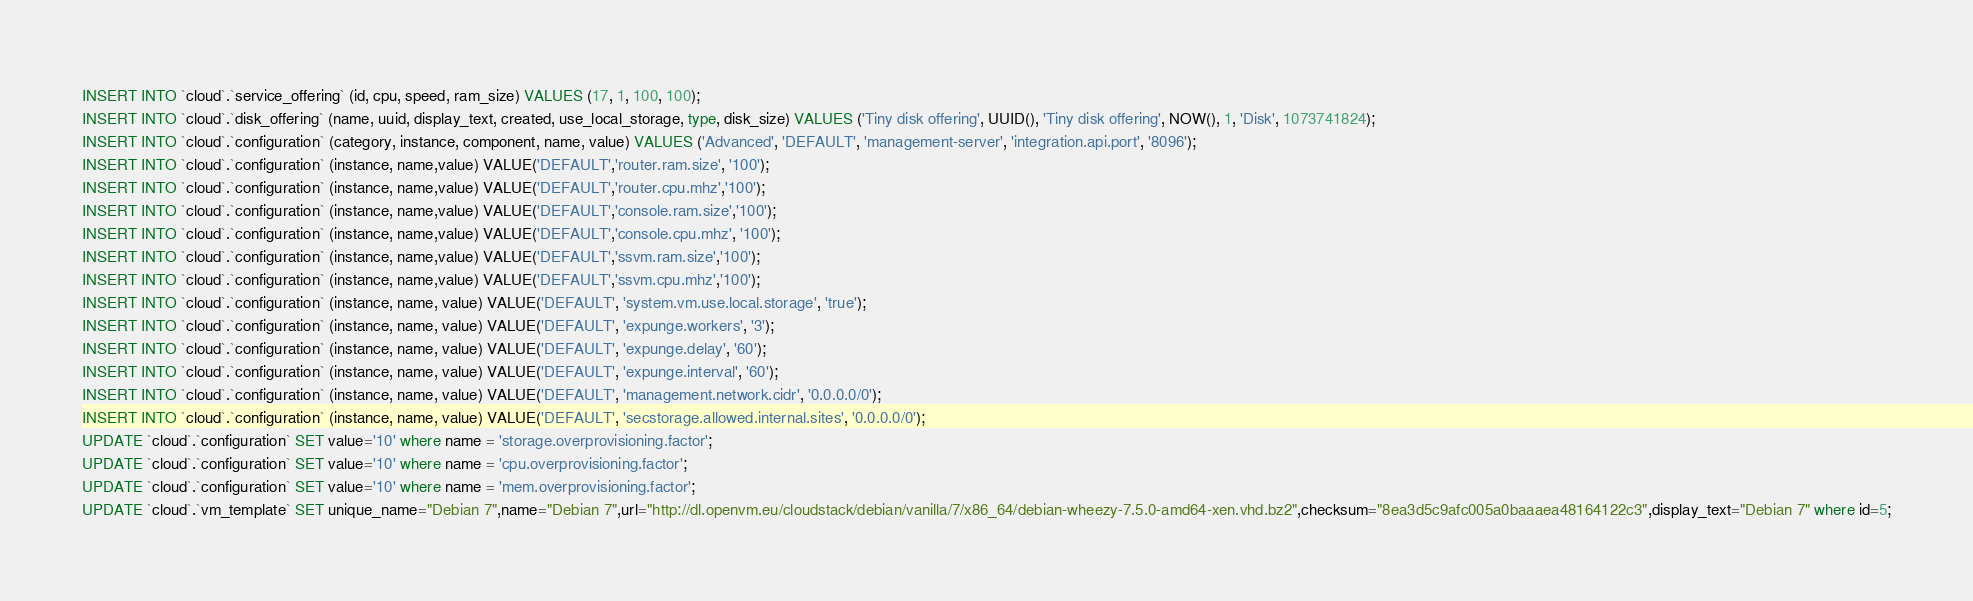<code> <loc_0><loc_0><loc_500><loc_500><_SQL_>INSERT INTO `cloud`.`service_offering` (id, cpu, speed, ram_size) VALUES (17, 1, 100, 100);
INSERT INTO `cloud`.`disk_offering` (name, uuid, display_text, created, use_local_storage, type, disk_size) VALUES ('Tiny disk offering', UUID(), 'Tiny disk offering', NOW(), 1, 'Disk', 1073741824);
INSERT INTO `cloud`.`configuration` (category, instance, component, name, value) VALUES ('Advanced', 'DEFAULT', 'management-server', 'integration.api.port', '8096');
INSERT INTO `cloud`.`configuration` (instance, name,value) VALUE('DEFAULT','router.ram.size', '100');
INSERT INTO `cloud`.`configuration` (instance, name,value) VALUE('DEFAULT','router.cpu.mhz','100');
INSERT INTO `cloud`.`configuration` (instance, name,value) VALUE('DEFAULT','console.ram.size','100');
INSERT INTO `cloud`.`configuration` (instance, name,value) VALUE('DEFAULT','console.cpu.mhz', '100');
INSERT INTO `cloud`.`configuration` (instance, name,value) VALUE('DEFAULT','ssvm.ram.size','100');
INSERT INTO `cloud`.`configuration` (instance, name,value) VALUE('DEFAULT','ssvm.cpu.mhz','100');
INSERT INTO `cloud`.`configuration` (instance, name, value) VALUE('DEFAULT', 'system.vm.use.local.storage', 'true');
INSERT INTO `cloud`.`configuration` (instance, name, value) VALUE('DEFAULT', 'expunge.workers', '3');
INSERT INTO `cloud`.`configuration` (instance, name, value) VALUE('DEFAULT', 'expunge.delay', '60');
INSERT INTO `cloud`.`configuration` (instance, name, value) VALUE('DEFAULT', 'expunge.interval', '60');
INSERT INTO `cloud`.`configuration` (instance, name, value) VALUE('DEFAULT', 'management.network.cidr', '0.0.0.0/0');
INSERT INTO `cloud`.`configuration` (instance, name, value) VALUE('DEFAULT', 'secstorage.allowed.internal.sites', '0.0.0.0/0');
UPDATE `cloud`.`configuration` SET value='10' where name = 'storage.overprovisioning.factor';
UPDATE `cloud`.`configuration` SET value='10' where name = 'cpu.overprovisioning.factor';
UPDATE `cloud`.`configuration` SET value='10' where name = 'mem.overprovisioning.factor';
UPDATE `cloud`.`vm_template` SET unique_name="Debian 7",name="Debian 7",url="http://dl.openvm.eu/cloudstack/debian/vanilla/7/x86_64/debian-wheezy-7.5.0-amd64-xen.vhd.bz2",checksum="8ea3d5c9afc005a0baaaea48164122c3",display_text="Debian 7" where id=5;</code> 